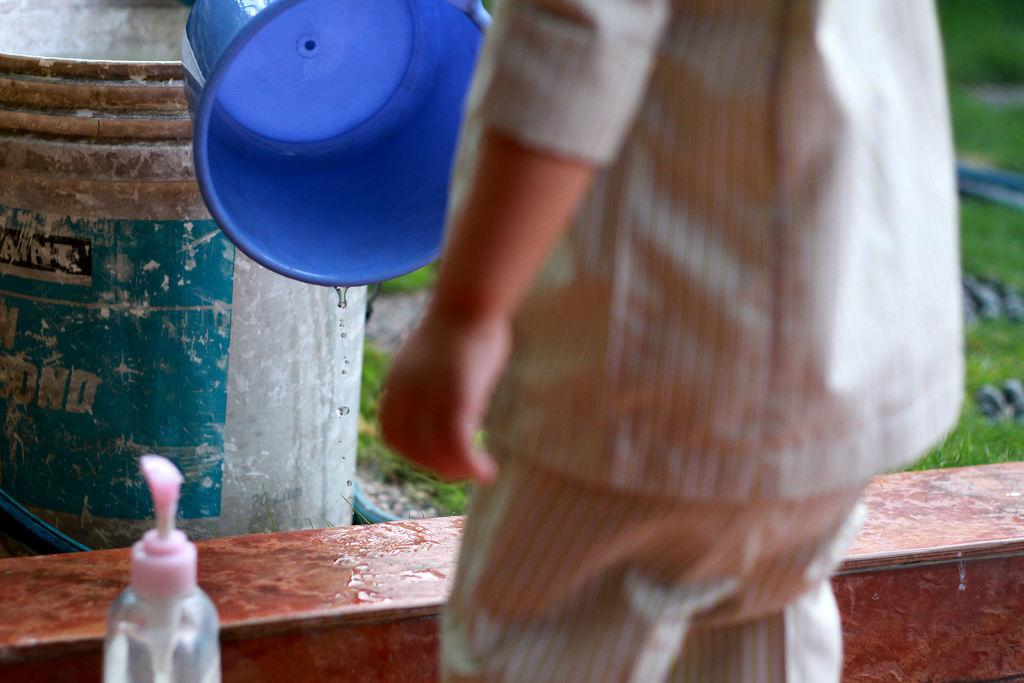Who is the main subject in the image? There is a child in the image. What object can be seen near the child? There is a soap dispenser in the image. What can be seen in the background of the image? There are buckets in the background of the image. What type of terrain is visible in the image? Grass is present on the ground in the image. What type of table is being used to cover the child in the image? There is no table present in the image, nor is the child being covered by anything. 